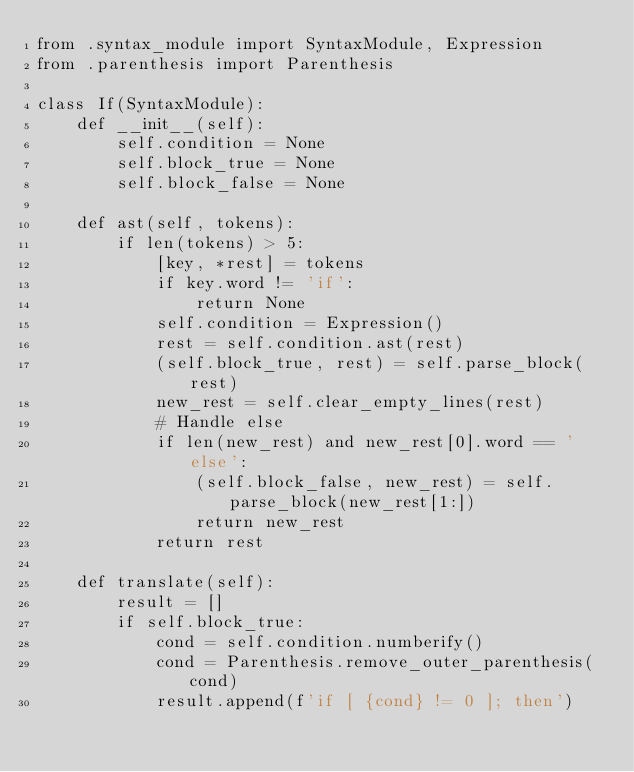<code> <loc_0><loc_0><loc_500><loc_500><_Python_>from .syntax_module import SyntaxModule, Expression
from .parenthesis import Parenthesis

class If(SyntaxModule):
    def __init__(self):
        self.condition = None
        self.block_true = None
        self.block_false = None
    
    def ast(self, tokens):
        if len(tokens) > 5:
            [key, *rest] = tokens
            if key.word != 'if':
                return None
            self.condition = Expression()
            rest = self.condition.ast(rest)
            (self.block_true, rest) = self.parse_block(rest)
            new_rest = self.clear_empty_lines(rest)
            # Handle else
            if len(new_rest) and new_rest[0].word == 'else':
                (self.block_false, new_rest) = self.parse_block(new_rest[1:])
                return new_rest
            return rest
    
    def translate(self):
        result = []
        if self.block_true:
            cond = self.condition.numberify()
            cond = Parenthesis.remove_outer_parenthesis(cond)
            result.append(f'if [ {cond} != 0 ]; then')</code> 